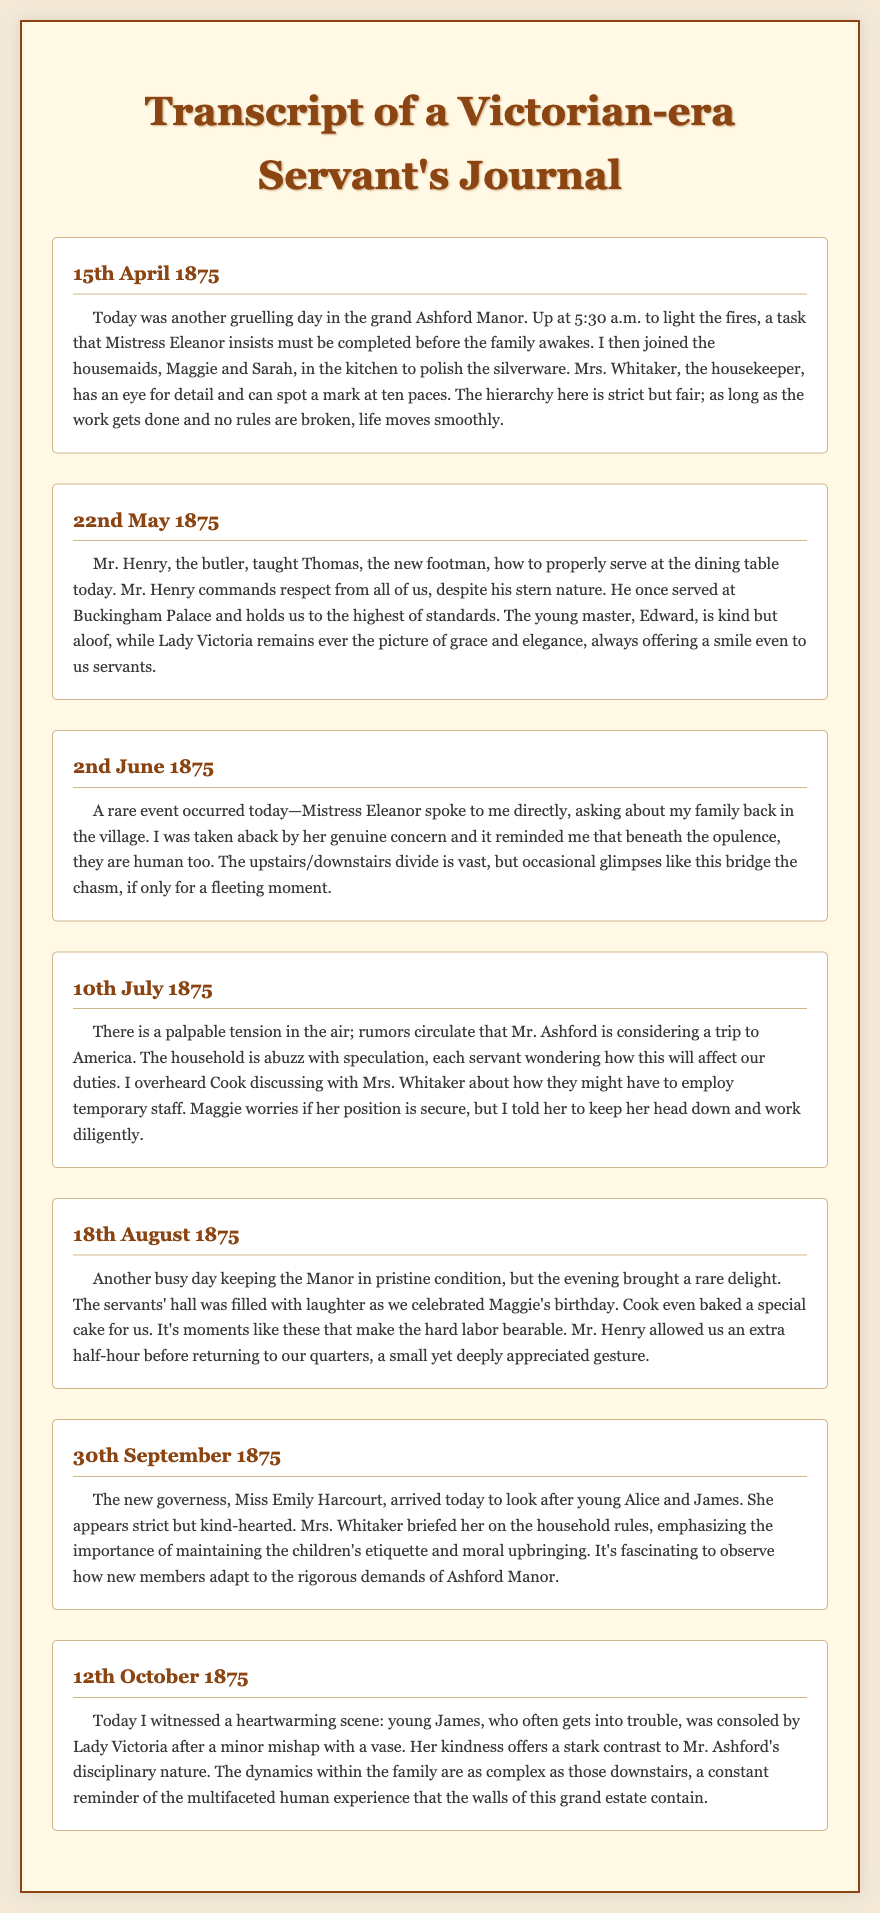what date did the governess arrive? The governess, Miss Emily Harcourt, arrived on 30th September 1875.
Answer: 30th September 1875 who is the housekeeper? The housekeeper in the journal is Mrs. Whitaker.
Answer: Mrs. Whitaker what time does the servant wake up? The servant wakes up at 5:30 a.m. to light the fires.
Answer: 5:30 a.m how does Lady Victoria interact with the servants? Lady Victoria remains ever the picture of grace and elegance, always offering a smile even to the servants.
Answer: Offering a smile what task did Mr. Henry teach Thomas? Mr. Henry taught Thomas how to properly serve at the dining table.
Answer: Serve at the dining table which event brought joy to the servants on 18th August 1875? The servants celebrated Maggie's birthday with a special cake.
Answer: Maggie's birthday what is a significant relationship mentioned in the journal? A significant relationship is the occasional conversations between Mistress Eleanor and the servant.
Answer: Conversations with Mistress Eleanor what did the servant observe about Lady Victoria and Mr. Ashford's behavior? The servant noted that Lady Victoria's kindness contrasts with Mr. Ashford's disciplinary nature.
Answer: Kindness contrasts with Mr. Ashford's when did the servant describe a palpable tension in the air? The servant described palpable tension in the air on 10th July 1875.
Answer: 10th July 1875 